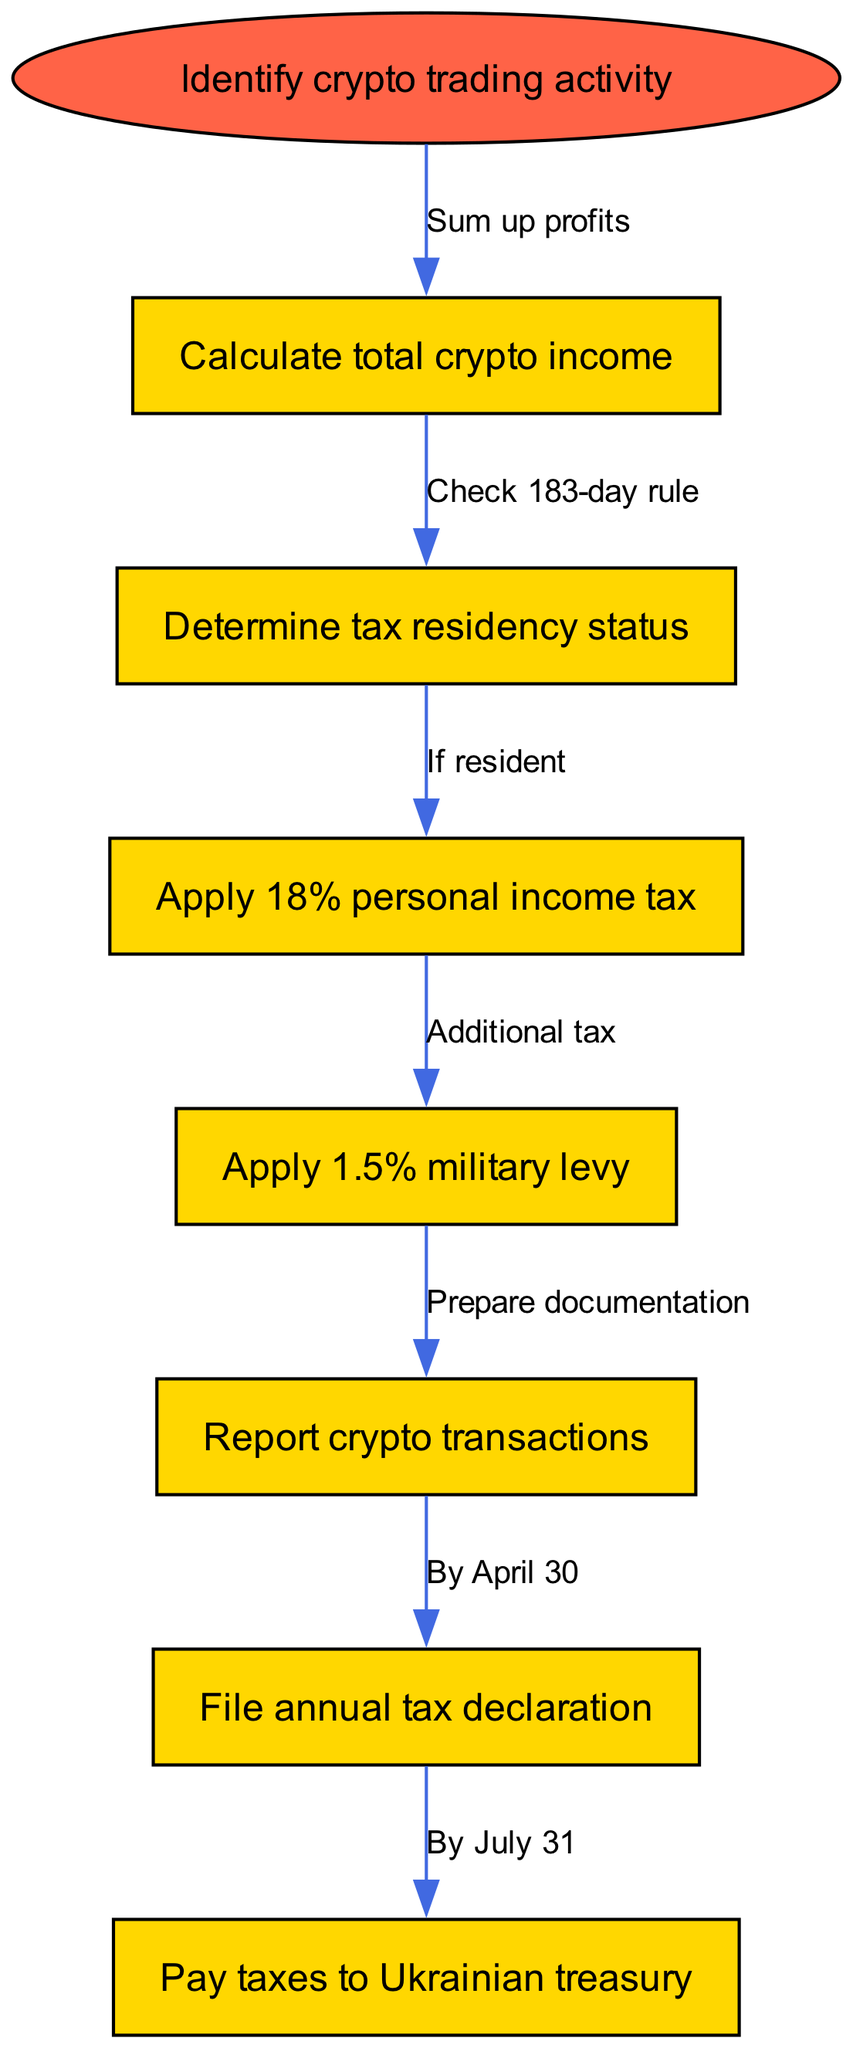What is the first step in the pathway? The first step is identified as "Identify crypto trading activity". It serves as the initiation point for the entire compliance process.
Answer: Identify crypto trading activity How many nodes are in the diagram? The diagram consists of 8 nodes, including the starting node and 7 subsequent actions. Each action represents a critical step in the taxation compliance process.
Answer: 8 What is the label on the edge from "Calculate total crypto income" to "Determine tax residency status"? The label on this edge is "Check 183-day rule". It indicates the condition that needs to be assessed after calculating total crypto income.
Answer: Check 183-day rule What tax rate is applied after determining tax residency status? The tax rate applied is 18% for personal income tax. This follows the determination of residency status.
Answer: 18% Which step comes after applying the military levy? After applying the 1.5% military levy, the next step is "Report crypto transactions". This step involves preparing the necessary documentation for reporting.
Answer: Report crypto transactions If a trader is a non-resident, what specific step is bypassed? If a trader is a non-resident, they would bypass the "Apply 18% personal income tax" step, as this applies only to residents.
Answer: Apply 18% personal income tax By what date must crypto transactions be reported? The transactions must be reported by April 30. This is a deadline highlighted in the pathway for filing the annual tax declaration.
Answer: By April 30 What is the last action before paying taxes to the Ukrainian treasury? The last action before paying taxes is "File annual tax declaration". This step is crucial and directly precedes the payment of taxes.
Answer: File annual tax declaration 